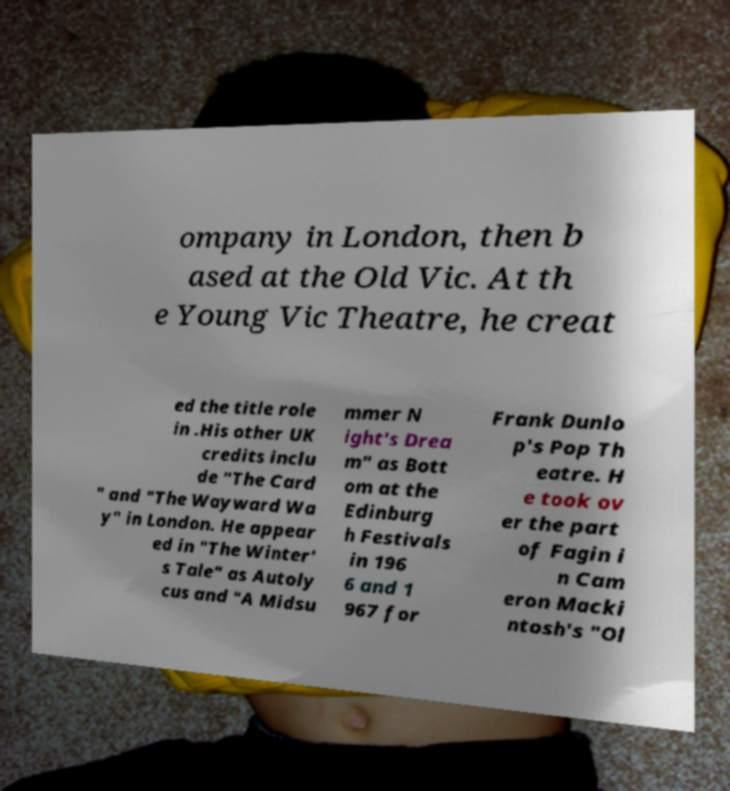Can you read and provide the text displayed in the image?This photo seems to have some interesting text. Can you extract and type it out for me? ompany in London, then b ased at the Old Vic. At th e Young Vic Theatre, he creat ed the title role in .His other UK credits inclu de "The Card " and "The Wayward Wa y" in London. He appear ed in "The Winter' s Tale" as Autoly cus and "A Midsu mmer N ight's Drea m" as Bott om at the Edinburg h Festivals in 196 6 and 1 967 for Frank Dunlo p's Pop Th eatre. H e took ov er the part of Fagin i n Cam eron Macki ntosh's "Ol 